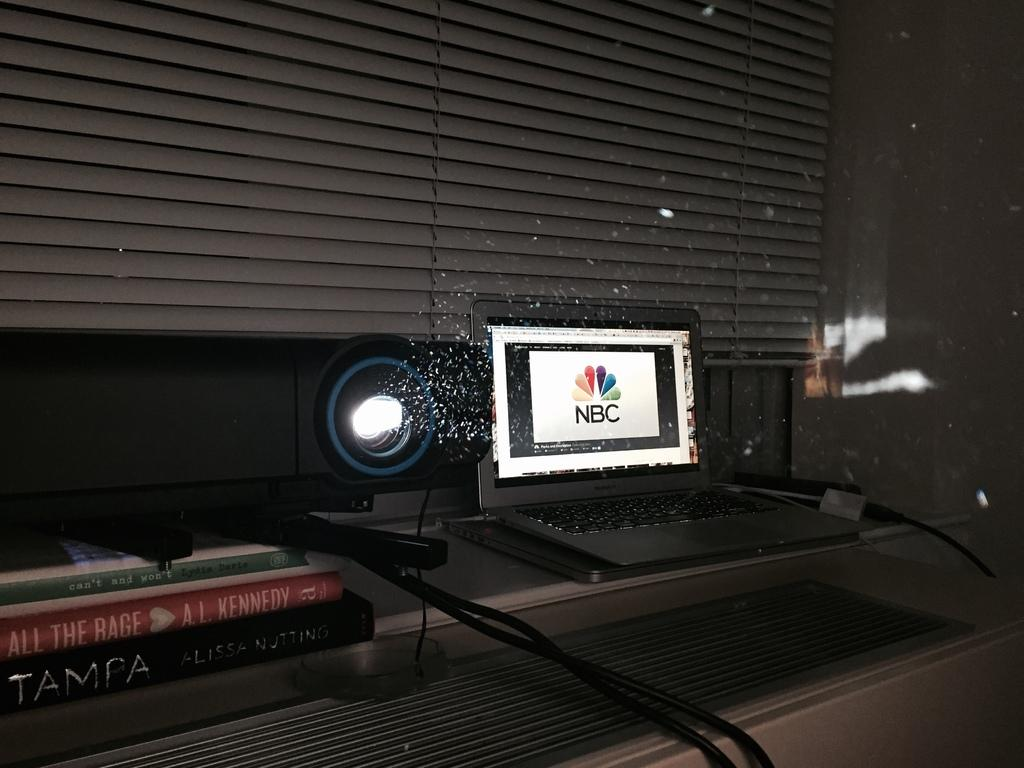<image>
Provide a brief description of the given image. NBC showing a monitor in a dark room. 